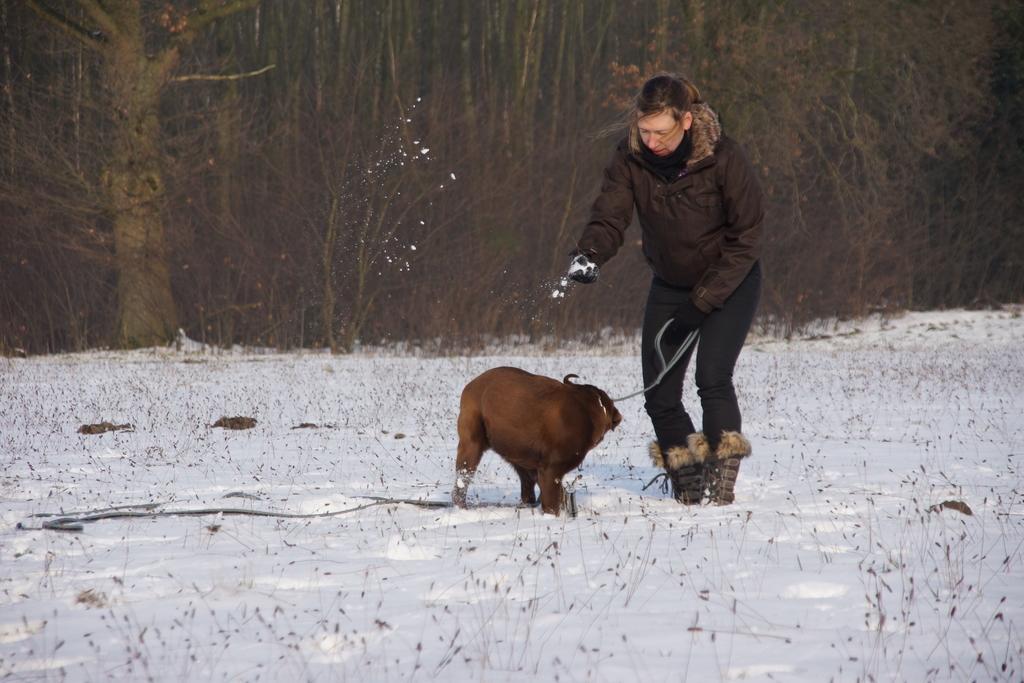Please provide a concise description of this image. At the bottom of this image I can see the snow. In the middle of the image there is a person wearing a jacket and holding the belt of an animal. In the right hand holding the snow. In the background there are many trees. 